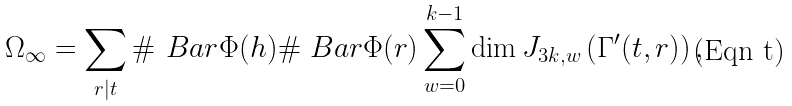Convert formula to latex. <formula><loc_0><loc_0><loc_500><loc_500>\Omega _ { \infty } = \sum _ { r | t } \# \ B a r \Phi ( h ) \# \ B a r \Phi ( r ) \sum _ { w = 0 } ^ { k - 1 } \dim J _ { 3 k , w } \left ( \Gamma ^ { \prime } ( t , r ) \right ) ,</formula> 